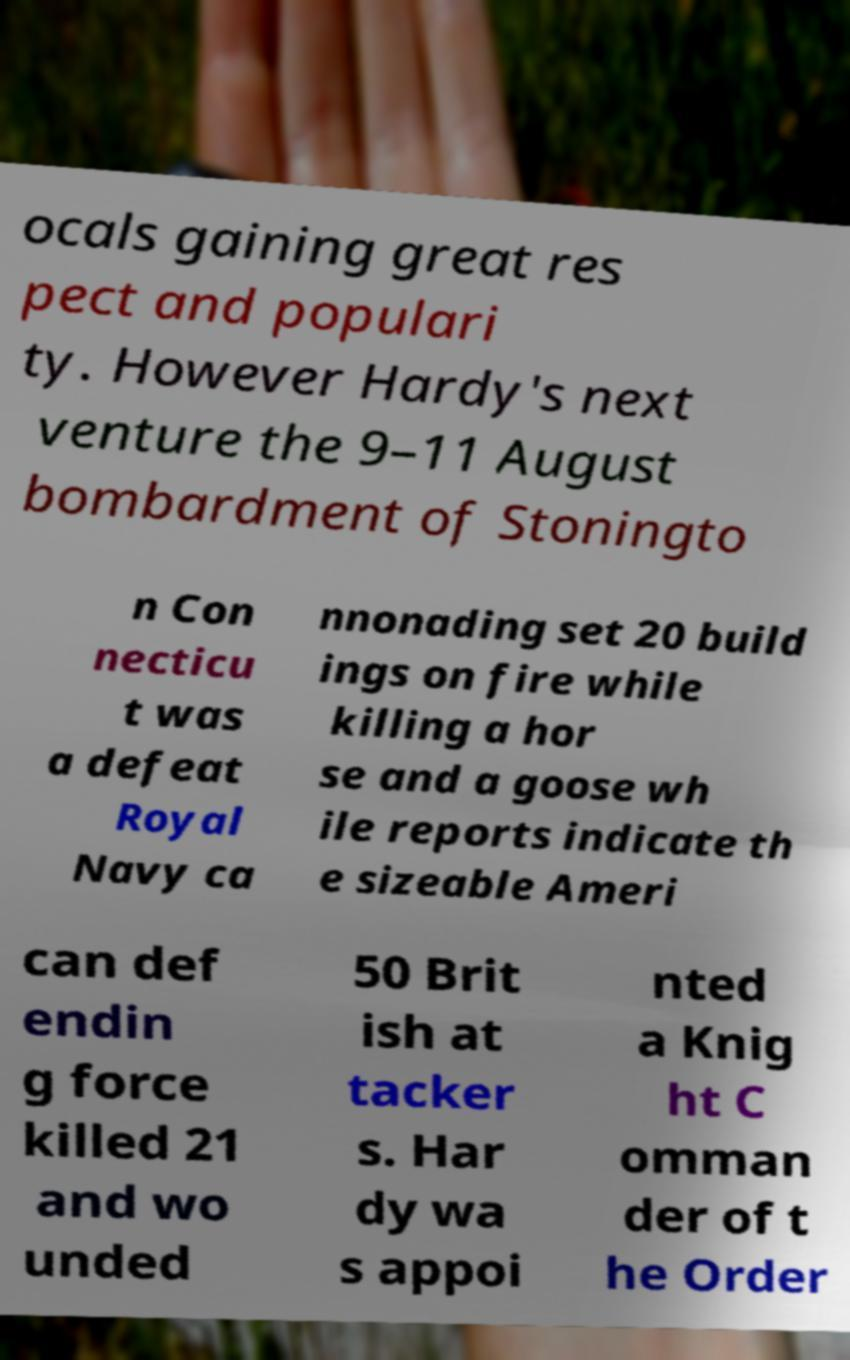What messages or text are displayed in this image? I need them in a readable, typed format. ocals gaining great res pect and populari ty. However Hardy's next venture the 9–11 August bombardment of Stoningto n Con necticu t was a defeat Royal Navy ca nnonading set 20 build ings on fire while killing a hor se and a goose wh ile reports indicate th e sizeable Ameri can def endin g force killed 21 and wo unded 50 Brit ish at tacker s. Har dy wa s appoi nted a Knig ht C omman der of t he Order 